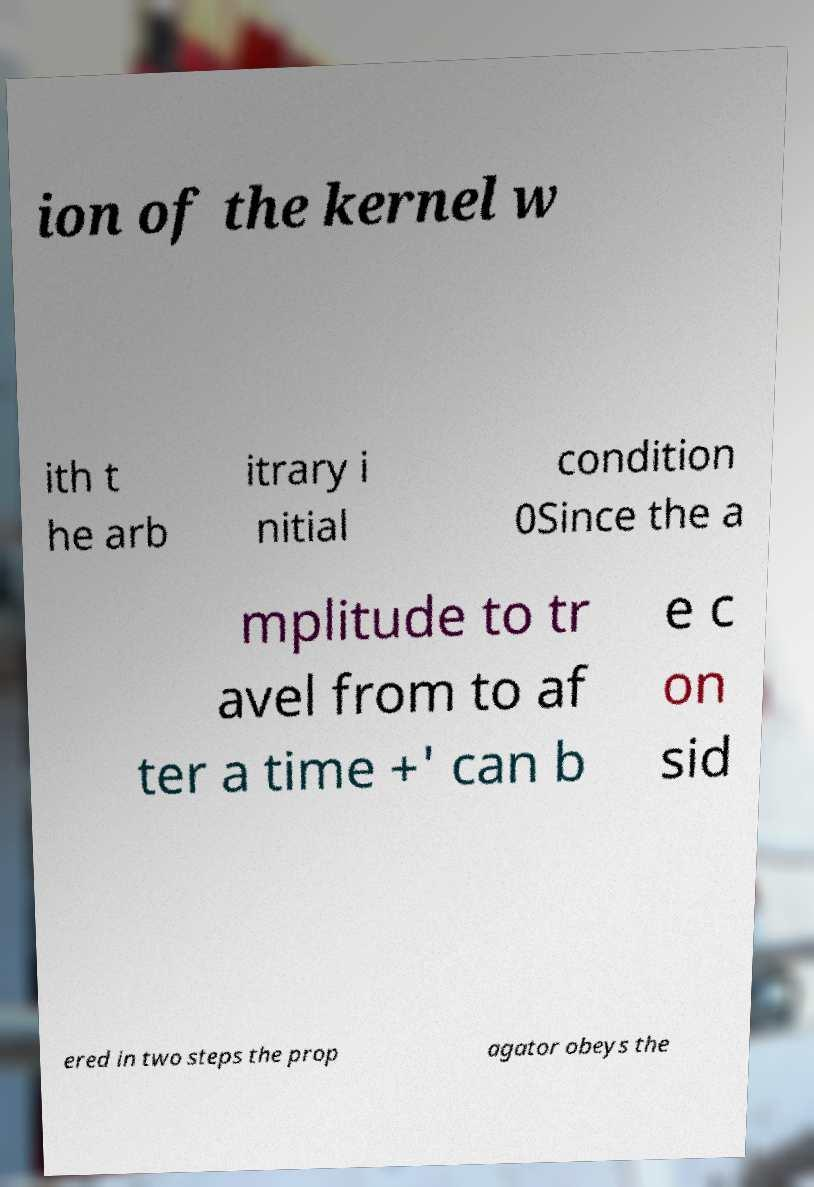There's text embedded in this image that I need extracted. Can you transcribe it verbatim? ion of the kernel w ith t he arb itrary i nitial condition 0Since the a mplitude to tr avel from to af ter a time +' can b e c on sid ered in two steps the prop agator obeys the 